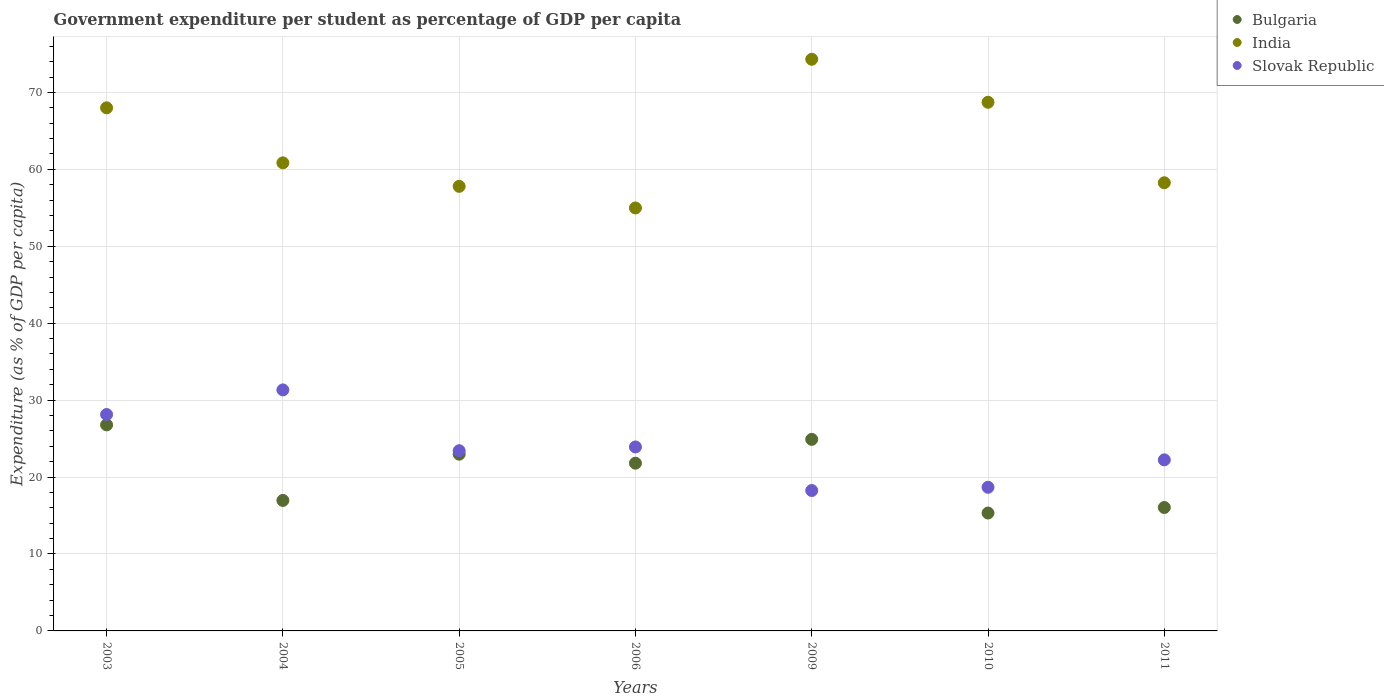What is the percentage of expenditure per student in Bulgaria in 2009?
Your answer should be compact. 24.9. Across all years, what is the maximum percentage of expenditure per student in Bulgaria?
Ensure brevity in your answer.  26.78. Across all years, what is the minimum percentage of expenditure per student in India?
Ensure brevity in your answer.  54.98. In which year was the percentage of expenditure per student in India maximum?
Provide a short and direct response. 2009. What is the total percentage of expenditure per student in India in the graph?
Your answer should be very brief. 442.9. What is the difference between the percentage of expenditure per student in India in 2003 and that in 2004?
Make the answer very short. 7.15. What is the difference between the percentage of expenditure per student in Slovak Republic in 2004 and the percentage of expenditure per student in India in 2009?
Your answer should be compact. -42.98. What is the average percentage of expenditure per student in Slovak Republic per year?
Give a very brief answer. 23.71. In the year 2005, what is the difference between the percentage of expenditure per student in Bulgaria and percentage of expenditure per student in India?
Offer a terse response. -34.82. What is the ratio of the percentage of expenditure per student in Slovak Republic in 2006 to that in 2011?
Offer a terse response. 1.08. Is the difference between the percentage of expenditure per student in Bulgaria in 2006 and 2010 greater than the difference between the percentage of expenditure per student in India in 2006 and 2010?
Ensure brevity in your answer.  Yes. What is the difference between the highest and the second highest percentage of expenditure per student in Slovak Republic?
Your answer should be very brief. 3.2. What is the difference between the highest and the lowest percentage of expenditure per student in Slovak Republic?
Your answer should be compact. 13.08. In how many years, is the percentage of expenditure per student in Slovak Republic greater than the average percentage of expenditure per student in Slovak Republic taken over all years?
Provide a short and direct response. 3. Does the percentage of expenditure per student in Slovak Republic monotonically increase over the years?
Make the answer very short. No. Is the percentage of expenditure per student in Slovak Republic strictly greater than the percentage of expenditure per student in Bulgaria over the years?
Provide a short and direct response. No. How many years are there in the graph?
Make the answer very short. 7. What is the difference between two consecutive major ticks on the Y-axis?
Offer a very short reply. 10. Where does the legend appear in the graph?
Make the answer very short. Top right. How many legend labels are there?
Your answer should be very brief. 3. How are the legend labels stacked?
Your answer should be compact. Vertical. What is the title of the graph?
Provide a short and direct response. Government expenditure per student as percentage of GDP per capita. What is the label or title of the X-axis?
Your answer should be very brief. Years. What is the label or title of the Y-axis?
Provide a succinct answer. Expenditure (as % of GDP per capita). What is the Expenditure (as % of GDP per capita) in Bulgaria in 2003?
Ensure brevity in your answer.  26.78. What is the Expenditure (as % of GDP per capita) of India in 2003?
Provide a short and direct response. 68. What is the Expenditure (as % of GDP per capita) in Slovak Republic in 2003?
Your answer should be very brief. 28.13. What is the Expenditure (as % of GDP per capita) of Bulgaria in 2004?
Provide a succinct answer. 16.96. What is the Expenditure (as % of GDP per capita) in India in 2004?
Your answer should be compact. 60.85. What is the Expenditure (as % of GDP per capita) in Slovak Republic in 2004?
Offer a terse response. 31.33. What is the Expenditure (as % of GDP per capita) in Bulgaria in 2005?
Your answer should be compact. 22.97. What is the Expenditure (as % of GDP per capita) in India in 2005?
Your response must be concise. 57.79. What is the Expenditure (as % of GDP per capita) of Slovak Republic in 2005?
Your answer should be very brief. 23.43. What is the Expenditure (as % of GDP per capita) of Bulgaria in 2006?
Provide a succinct answer. 21.8. What is the Expenditure (as % of GDP per capita) in India in 2006?
Offer a terse response. 54.98. What is the Expenditure (as % of GDP per capita) of Slovak Republic in 2006?
Provide a short and direct response. 23.92. What is the Expenditure (as % of GDP per capita) of Bulgaria in 2009?
Your response must be concise. 24.9. What is the Expenditure (as % of GDP per capita) in India in 2009?
Provide a short and direct response. 74.31. What is the Expenditure (as % of GDP per capita) of Slovak Republic in 2009?
Make the answer very short. 18.25. What is the Expenditure (as % of GDP per capita) in Bulgaria in 2010?
Your response must be concise. 15.33. What is the Expenditure (as % of GDP per capita) of India in 2010?
Offer a terse response. 68.72. What is the Expenditure (as % of GDP per capita) in Slovak Republic in 2010?
Offer a terse response. 18.67. What is the Expenditure (as % of GDP per capita) of Bulgaria in 2011?
Make the answer very short. 16.04. What is the Expenditure (as % of GDP per capita) of India in 2011?
Make the answer very short. 58.26. What is the Expenditure (as % of GDP per capita) of Slovak Republic in 2011?
Your answer should be compact. 22.24. Across all years, what is the maximum Expenditure (as % of GDP per capita) in Bulgaria?
Ensure brevity in your answer.  26.78. Across all years, what is the maximum Expenditure (as % of GDP per capita) of India?
Give a very brief answer. 74.31. Across all years, what is the maximum Expenditure (as % of GDP per capita) in Slovak Republic?
Provide a succinct answer. 31.33. Across all years, what is the minimum Expenditure (as % of GDP per capita) in Bulgaria?
Provide a succinct answer. 15.33. Across all years, what is the minimum Expenditure (as % of GDP per capita) of India?
Your answer should be compact. 54.98. Across all years, what is the minimum Expenditure (as % of GDP per capita) of Slovak Republic?
Provide a succinct answer. 18.25. What is the total Expenditure (as % of GDP per capita) in Bulgaria in the graph?
Make the answer very short. 144.8. What is the total Expenditure (as % of GDP per capita) of India in the graph?
Keep it short and to the point. 442.9. What is the total Expenditure (as % of GDP per capita) of Slovak Republic in the graph?
Make the answer very short. 165.96. What is the difference between the Expenditure (as % of GDP per capita) in Bulgaria in 2003 and that in 2004?
Ensure brevity in your answer.  9.82. What is the difference between the Expenditure (as % of GDP per capita) of India in 2003 and that in 2004?
Make the answer very short. 7.15. What is the difference between the Expenditure (as % of GDP per capita) in Slovak Republic in 2003 and that in 2004?
Offer a very short reply. -3.2. What is the difference between the Expenditure (as % of GDP per capita) in Bulgaria in 2003 and that in 2005?
Provide a short and direct response. 3.81. What is the difference between the Expenditure (as % of GDP per capita) in India in 2003 and that in 2005?
Make the answer very short. 10.21. What is the difference between the Expenditure (as % of GDP per capita) in Slovak Republic in 2003 and that in 2005?
Make the answer very short. 4.7. What is the difference between the Expenditure (as % of GDP per capita) of Bulgaria in 2003 and that in 2006?
Your response must be concise. 4.98. What is the difference between the Expenditure (as % of GDP per capita) of India in 2003 and that in 2006?
Your answer should be compact. 13.02. What is the difference between the Expenditure (as % of GDP per capita) of Slovak Republic in 2003 and that in 2006?
Your response must be concise. 4.21. What is the difference between the Expenditure (as % of GDP per capita) in Bulgaria in 2003 and that in 2009?
Keep it short and to the point. 1.88. What is the difference between the Expenditure (as % of GDP per capita) in India in 2003 and that in 2009?
Provide a short and direct response. -6.31. What is the difference between the Expenditure (as % of GDP per capita) of Slovak Republic in 2003 and that in 2009?
Your response must be concise. 9.88. What is the difference between the Expenditure (as % of GDP per capita) in Bulgaria in 2003 and that in 2010?
Provide a succinct answer. 11.46. What is the difference between the Expenditure (as % of GDP per capita) of India in 2003 and that in 2010?
Keep it short and to the point. -0.72. What is the difference between the Expenditure (as % of GDP per capita) in Slovak Republic in 2003 and that in 2010?
Your answer should be very brief. 9.46. What is the difference between the Expenditure (as % of GDP per capita) in Bulgaria in 2003 and that in 2011?
Offer a very short reply. 10.74. What is the difference between the Expenditure (as % of GDP per capita) of India in 2003 and that in 2011?
Provide a short and direct response. 9.74. What is the difference between the Expenditure (as % of GDP per capita) of Slovak Republic in 2003 and that in 2011?
Offer a terse response. 5.89. What is the difference between the Expenditure (as % of GDP per capita) in Bulgaria in 2004 and that in 2005?
Ensure brevity in your answer.  -6.01. What is the difference between the Expenditure (as % of GDP per capita) in India in 2004 and that in 2005?
Offer a terse response. 3.06. What is the difference between the Expenditure (as % of GDP per capita) of Slovak Republic in 2004 and that in 2005?
Ensure brevity in your answer.  7.9. What is the difference between the Expenditure (as % of GDP per capita) of Bulgaria in 2004 and that in 2006?
Your answer should be very brief. -4.84. What is the difference between the Expenditure (as % of GDP per capita) in India in 2004 and that in 2006?
Your response must be concise. 5.87. What is the difference between the Expenditure (as % of GDP per capita) in Slovak Republic in 2004 and that in 2006?
Make the answer very short. 7.42. What is the difference between the Expenditure (as % of GDP per capita) of Bulgaria in 2004 and that in 2009?
Offer a terse response. -7.94. What is the difference between the Expenditure (as % of GDP per capita) of India in 2004 and that in 2009?
Ensure brevity in your answer.  -13.47. What is the difference between the Expenditure (as % of GDP per capita) in Slovak Republic in 2004 and that in 2009?
Provide a short and direct response. 13.08. What is the difference between the Expenditure (as % of GDP per capita) in Bulgaria in 2004 and that in 2010?
Ensure brevity in your answer.  1.64. What is the difference between the Expenditure (as % of GDP per capita) of India in 2004 and that in 2010?
Your answer should be very brief. -7.87. What is the difference between the Expenditure (as % of GDP per capita) in Slovak Republic in 2004 and that in 2010?
Make the answer very short. 12.66. What is the difference between the Expenditure (as % of GDP per capita) of Bulgaria in 2004 and that in 2011?
Make the answer very short. 0.92. What is the difference between the Expenditure (as % of GDP per capita) in India in 2004 and that in 2011?
Keep it short and to the point. 2.59. What is the difference between the Expenditure (as % of GDP per capita) in Slovak Republic in 2004 and that in 2011?
Make the answer very short. 9.09. What is the difference between the Expenditure (as % of GDP per capita) of Bulgaria in 2005 and that in 2006?
Your answer should be compact. 1.17. What is the difference between the Expenditure (as % of GDP per capita) in India in 2005 and that in 2006?
Provide a short and direct response. 2.81. What is the difference between the Expenditure (as % of GDP per capita) in Slovak Republic in 2005 and that in 2006?
Provide a short and direct response. -0.49. What is the difference between the Expenditure (as % of GDP per capita) in Bulgaria in 2005 and that in 2009?
Provide a short and direct response. -1.93. What is the difference between the Expenditure (as % of GDP per capita) in India in 2005 and that in 2009?
Your answer should be compact. -16.52. What is the difference between the Expenditure (as % of GDP per capita) of Slovak Republic in 2005 and that in 2009?
Provide a short and direct response. 5.18. What is the difference between the Expenditure (as % of GDP per capita) of Bulgaria in 2005 and that in 2010?
Offer a terse response. 7.65. What is the difference between the Expenditure (as % of GDP per capita) of India in 2005 and that in 2010?
Provide a short and direct response. -10.93. What is the difference between the Expenditure (as % of GDP per capita) of Slovak Republic in 2005 and that in 2010?
Make the answer very short. 4.75. What is the difference between the Expenditure (as % of GDP per capita) of Bulgaria in 2005 and that in 2011?
Your answer should be compact. 6.93. What is the difference between the Expenditure (as % of GDP per capita) of India in 2005 and that in 2011?
Ensure brevity in your answer.  -0.47. What is the difference between the Expenditure (as % of GDP per capita) in Slovak Republic in 2005 and that in 2011?
Give a very brief answer. 1.19. What is the difference between the Expenditure (as % of GDP per capita) of Bulgaria in 2006 and that in 2009?
Offer a terse response. -3.1. What is the difference between the Expenditure (as % of GDP per capita) in India in 2006 and that in 2009?
Offer a terse response. -19.33. What is the difference between the Expenditure (as % of GDP per capita) in Slovak Republic in 2006 and that in 2009?
Give a very brief answer. 5.66. What is the difference between the Expenditure (as % of GDP per capita) in Bulgaria in 2006 and that in 2010?
Make the answer very short. 6.48. What is the difference between the Expenditure (as % of GDP per capita) in India in 2006 and that in 2010?
Ensure brevity in your answer.  -13.74. What is the difference between the Expenditure (as % of GDP per capita) of Slovak Republic in 2006 and that in 2010?
Your answer should be very brief. 5.24. What is the difference between the Expenditure (as % of GDP per capita) of Bulgaria in 2006 and that in 2011?
Make the answer very short. 5.76. What is the difference between the Expenditure (as % of GDP per capita) in India in 2006 and that in 2011?
Your answer should be very brief. -3.28. What is the difference between the Expenditure (as % of GDP per capita) in Slovak Republic in 2006 and that in 2011?
Offer a very short reply. 1.68. What is the difference between the Expenditure (as % of GDP per capita) in Bulgaria in 2009 and that in 2010?
Your response must be concise. 9.58. What is the difference between the Expenditure (as % of GDP per capita) of India in 2009 and that in 2010?
Keep it short and to the point. 5.59. What is the difference between the Expenditure (as % of GDP per capita) in Slovak Republic in 2009 and that in 2010?
Provide a short and direct response. -0.42. What is the difference between the Expenditure (as % of GDP per capita) of Bulgaria in 2009 and that in 2011?
Provide a succinct answer. 8.86. What is the difference between the Expenditure (as % of GDP per capita) in India in 2009 and that in 2011?
Your answer should be very brief. 16.05. What is the difference between the Expenditure (as % of GDP per capita) of Slovak Republic in 2009 and that in 2011?
Offer a terse response. -3.99. What is the difference between the Expenditure (as % of GDP per capita) of Bulgaria in 2010 and that in 2011?
Offer a very short reply. -0.72. What is the difference between the Expenditure (as % of GDP per capita) of India in 2010 and that in 2011?
Offer a very short reply. 10.46. What is the difference between the Expenditure (as % of GDP per capita) of Slovak Republic in 2010 and that in 2011?
Make the answer very short. -3.56. What is the difference between the Expenditure (as % of GDP per capita) of Bulgaria in 2003 and the Expenditure (as % of GDP per capita) of India in 2004?
Make the answer very short. -34.06. What is the difference between the Expenditure (as % of GDP per capita) of Bulgaria in 2003 and the Expenditure (as % of GDP per capita) of Slovak Republic in 2004?
Make the answer very short. -4.55. What is the difference between the Expenditure (as % of GDP per capita) in India in 2003 and the Expenditure (as % of GDP per capita) in Slovak Republic in 2004?
Provide a short and direct response. 36.67. What is the difference between the Expenditure (as % of GDP per capita) in Bulgaria in 2003 and the Expenditure (as % of GDP per capita) in India in 2005?
Your response must be concise. -31.01. What is the difference between the Expenditure (as % of GDP per capita) in Bulgaria in 2003 and the Expenditure (as % of GDP per capita) in Slovak Republic in 2005?
Your answer should be compact. 3.36. What is the difference between the Expenditure (as % of GDP per capita) in India in 2003 and the Expenditure (as % of GDP per capita) in Slovak Republic in 2005?
Ensure brevity in your answer.  44.57. What is the difference between the Expenditure (as % of GDP per capita) of Bulgaria in 2003 and the Expenditure (as % of GDP per capita) of India in 2006?
Your response must be concise. -28.2. What is the difference between the Expenditure (as % of GDP per capita) of Bulgaria in 2003 and the Expenditure (as % of GDP per capita) of Slovak Republic in 2006?
Provide a succinct answer. 2.87. What is the difference between the Expenditure (as % of GDP per capita) of India in 2003 and the Expenditure (as % of GDP per capita) of Slovak Republic in 2006?
Make the answer very short. 44.08. What is the difference between the Expenditure (as % of GDP per capita) of Bulgaria in 2003 and the Expenditure (as % of GDP per capita) of India in 2009?
Offer a terse response. -47.53. What is the difference between the Expenditure (as % of GDP per capita) of Bulgaria in 2003 and the Expenditure (as % of GDP per capita) of Slovak Republic in 2009?
Ensure brevity in your answer.  8.53. What is the difference between the Expenditure (as % of GDP per capita) of India in 2003 and the Expenditure (as % of GDP per capita) of Slovak Republic in 2009?
Offer a very short reply. 49.75. What is the difference between the Expenditure (as % of GDP per capita) in Bulgaria in 2003 and the Expenditure (as % of GDP per capita) in India in 2010?
Ensure brevity in your answer.  -41.94. What is the difference between the Expenditure (as % of GDP per capita) in Bulgaria in 2003 and the Expenditure (as % of GDP per capita) in Slovak Republic in 2010?
Provide a short and direct response. 8.11. What is the difference between the Expenditure (as % of GDP per capita) in India in 2003 and the Expenditure (as % of GDP per capita) in Slovak Republic in 2010?
Provide a short and direct response. 49.33. What is the difference between the Expenditure (as % of GDP per capita) in Bulgaria in 2003 and the Expenditure (as % of GDP per capita) in India in 2011?
Give a very brief answer. -31.47. What is the difference between the Expenditure (as % of GDP per capita) of Bulgaria in 2003 and the Expenditure (as % of GDP per capita) of Slovak Republic in 2011?
Provide a succinct answer. 4.55. What is the difference between the Expenditure (as % of GDP per capita) of India in 2003 and the Expenditure (as % of GDP per capita) of Slovak Republic in 2011?
Your answer should be compact. 45.76. What is the difference between the Expenditure (as % of GDP per capita) of Bulgaria in 2004 and the Expenditure (as % of GDP per capita) of India in 2005?
Your response must be concise. -40.83. What is the difference between the Expenditure (as % of GDP per capita) of Bulgaria in 2004 and the Expenditure (as % of GDP per capita) of Slovak Republic in 2005?
Offer a terse response. -6.46. What is the difference between the Expenditure (as % of GDP per capita) of India in 2004 and the Expenditure (as % of GDP per capita) of Slovak Republic in 2005?
Your answer should be very brief. 37.42. What is the difference between the Expenditure (as % of GDP per capita) of Bulgaria in 2004 and the Expenditure (as % of GDP per capita) of India in 2006?
Ensure brevity in your answer.  -38.02. What is the difference between the Expenditure (as % of GDP per capita) in Bulgaria in 2004 and the Expenditure (as % of GDP per capita) in Slovak Republic in 2006?
Provide a short and direct response. -6.95. What is the difference between the Expenditure (as % of GDP per capita) of India in 2004 and the Expenditure (as % of GDP per capita) of Slovak Republic in 2006?
Your response must be concise. 36.93. What is the difference between the Expenditure (as % of GDP per capita) of Bulgaria in 2004 and the Expenditure (as % of GDP per capita) of India in 2009?
Offer a very short reply. -57.35. What is the difference between the Expenditure (as % of GDP per capita) of Bulgaria in 2004 and the Expenditure (as % of GDP per capita) of Slovak Republic in 2009?
Your answer should be compact. -1.29. What is the difference between the Expenditure (as % of GDP per capita) in India in 2004 and the Expenditure (as % of GDP per capita) in Slovak Republic in 2009?
Ensure brevity in your answer.  42.59. What is the difference between the Expenditure (as % of GDP per capita) in Bulgaria in 2004 and the Expenditure (as % of GDP per capita) in India in 2010?
Provide a succinct answer. -51.76. What is the difference between the Expenditure (as % of GDP per capita) in Bulgaria in 2004 and the Expenditure (as % of GDP per capita) in Slovak Republic in 2010?
Keep it short and to the point. -1.71. What is the difference between the Expenditure (as % of GDP per capita) of India in 2004 and the Expenditure (as % of GDP per capita) of Slovak Republic in 2010?
Provide a succinct answer. 42.17. What is the difference between the Expenditure (as % of GDP per capita) in Bulgaria in 2004 and the Expenditure (as % of GDP per capita) in India in 2011?
Offer a very short reply. -41.29. What is the difference between the Expenditure (as % of GDP per capita) in Bulgaria in 2004 and the Expenditure (as % of GDP per capita) in Slovak Republic in 2011?
Your answer should be compact. -5.27. What is the difference between the Expenditure (as % of GDP per capita) in India in 2004 and the Expenditure (as % of GDP per capita) in Slovak Republic in 2011?
Provide a succinct answer. 38.61. What is the difference between the Expenditure (as % of GDP per capita) in Bulgaria in 2005 and the Expenditure (as % of GDP per capita) in India in 2006?
Provide a short and direct response. -32.01. What is the difference between the Expenditure (as % of GDP per capita) in Bulgaria in 2005 and the Expenditure (as % of GDP per capita) in Slovak Republic in 2006?
Your answer should be very brief. -0.94. What is the difference between the Expenditure (as % of GDP per capita) of India in 2005 and the Expenditure (as % of GDP per capita) of Slovak Republic in 2006?
Offer a terse response. 33.87. What is the difference between the Expenditure (as % of GDP per capita) of Bulgaria in 2005 and the Expenditure (as % of GDP per capita) of India in 2009?
Provide a succinct answer. -51.34. What is the difference between the Expenditure (as % of GDP per capita) of Bulgaria in 2005 and the Expenditure (as % of GDP per capita) of Slovak Republic in 2009?
Ensure brevity in your answer.  4.72. What is the difference between the Expenditure (as % of GDP per capita) in India in 2005 and the Expenditure (as % of GDP per capita) in Slovak Republic in 2009?
Offer a very short reply. 39.54. What is the difference between the Expenditure (as % of GDP per capita) of Bulgaria in 2005 and the Expenditure (as % of GDP per capita) of India in 2010?
Provide a succinct answer. -45.75. What is the difference between the Expenditure (as % of GDP per capita) of Bulgaria in 2005 and the Expenditure (as % of GDP per capita) of Slovak Republic in 2010?
Offer a terse response. 4.3. What is the difference between the Expenditure (as % of GDP per capita) in India in 2005 and the Expenditure (as % of GDP per capita) in Slovak Republic in 2010?
Your response must be concise. 39.12. What is the difference between the Expenditure (as % of GDP per capita) of Bulgaria in 2005 and the Expenditure (as % of GDP per capita) of India in 2011?
Give a very brief answer. -35.28. What is the difference between the Expenditure (as % of GDP per capita) of Bulgaria in 2005 and the Expenditure (as % of GDP per capita) of Slovak Republic in 2011?
Your answer should be very brief. 0.74. What is the difference between the Expenditure (as % of GDP per capita) in India in 2005 and the Expenditure (as % of GDP per capita) in Slovak Republic in 2011?
Offer a very short reply. 35.55. What is the difference between the Expenditure (as % of GDP per capita) in Bulgaria in 2006 and the Expenditure (as % of GDP per capita) in India in 2009?
Keep it short and to the point. -52.51. What is the difference between the Expenditure (as % of GDP per capita) of Bulgaria in 2006 and the Expenditure (as % of GDP per capita) of Slovak Republic in 2009?
Offer a very short reply. 3.55. What is the difference between the Expenditure (as % of GDP per capita) in India in 2006 and the Expenditure (as % of GDP per capita) in Slovak Republic in 2009?
Offer a very short reply. 36.73. What is the difference between the Expenditure (as % of GDP per capita) of Bulgaria in 2006 and the Expenditure (as % of GDP per capita) of India in 2010?
Make the answer very short. -46.92. What is the difference between the Expenditure (as % of GDP per capita) in Bulgaria in 2006 and the Expenditure (as % of GDP per capita) in Slovak Republic in 2010?
Offer a very short reply. 3.13. What is the difference between the Expenditure (as % of GDP per capita) of India in 2006 and the Expenditure (as % of GDP per capita) of Slovak Republic in 2010?
Provide a short and direct response. 36.31. What is the difference between the Expenditure (as % of GDP per capita) in Bulgaria in 2006 and the Expenditure (as % of GDP per capita) in India in 2011?
Give a very brief answer. -36.45. What is the difference between the Expenditure (as % of GDP per capita) in Bulgaria in 2006 and the Expenditure (as % of GDP per capita) in Slovak Republic in 2011?
Give a very brief answer. -0.43. What is the difference between the Expenditure (as % of GDP per capita) in India in 2006 and the Expenditure (as % of GDP per capita) in Slovak Republic in 2011?
Offer a very short reply. 32.74. What is the difference between the Expenditure (as % of GDP per capita) of Bulgaria in 2009 and the Expenditure (as % of GDP per capita) of India in 2010?
Ensure brevity in your answer.  -43.82. What is the difference between the Expenditure (as % of GDP per capita) in Bulgaria in 2009 and the Expenditure (as % of GDP per capita) in Slovak Republic in 2010?
Provide a short and direct response. 6.23. What is the difference between the Expenditure (as % of GDP per capita) in India in 2009 and the Expenditure (as % of GDP per capita) in Slovak Republic in 2010?
Give a very brief answer. 55.64. What is the difference between the Expenditure (as % of GDP per capita) of Bulgaria in 2009 and the Expenditure (as % of GDP per capita) of India in 2011?
Provide a succinct answer. -33.35. What is the difference between the Expenditure (as % of GDP per capita) in Bulgaria in 2009 and the Expenditure (as % of GDP per capita) in Slovak Republic in 2011?
Provide a short and direct response. 2.66. What is the difference between the Expenditure (as % of GDP per capita) in India in 2009 and the Expenditure (as % of GDP per capita) in Slovak Republic in 2011?
Make the answer very short. 52.07. What is the difference between the Expenditure (as % of GDP per capita) of Bulgaria in 2010 and the Expenditure (as % of GDP per capita) of India in 2011?
Offer a terse response. -42.93. What is the difference between the Expenditure (as % of GDP per capita) in Bulgaria in 2010 and the Expenditure (as % of GDP per capita) in Slovak Republic in 2011?
Ensure brevity in your answer.  -6.91. What is the difference between the Expenditure (as % of GDP per capita) of India in 2010 and the Expenditure (as % of GDP per capita) of Slovak Republic in 2011?
Your answer should be compact. 46.48. What is the average Expenditure (as % of GDP per capita) of Bulgaria per year?
Offer a terse response. 20.68. What is the average Expenditure (as % of GDP per capita) of India per year?
Ensure brevity in your answer.  63.27. What is the average Expenditure (as % of GDP per capita) of Slovak Republic per year?
Provide a succinct answer. 23.71. In the year 2003, what is the difference between the Expenditure (as % of GDP per capita) in Bulgaria and Expenditure (as % of GDP per capita) in India?
Give a very brief answer. -41.21. In the year 2003, what is the difference between the Expenditure (as % of GDP per capita) of Bulgaria and Expenditure (as % of GDP per capita) of Slovak Republic?
Your answer should be very brief. -1.34. In the year 2003, what is the difference between the Expenditure (as % of GDP per capita) in India and Expenditure (as % of GDP per capita) in Slovak Republic?
Provide a short and direct response. 39.87. In the year 2004, what is the difference between the Expenditure (as % of GDP per capita) in Bulgaria and Expenditure (as % of GDP per capita) in India?
Ensure brevity in your answer.  -43.88. In the year 2004, what is the difference between the Expenditure (as % of GDP per capita) in Bulgaria and Expenditure (as % of GDP per capita) in Slovak Republic?
Keep it short and to the point. -14.37. In the year 2004, what is the difference between the Expenditure (as % of GDP per capita) in India and Expenditure (as % of GDP per capita) in Slovak Republic?
Offer a very short reply. 29.52. In the year 2005, what is the difference between the Expenditure (as % of GDP per capita) of Bulgaria and Expenditure (as % of GDP per capita) of India?
Your answer should be very brief. -34.82. In the year 2005, what is the difference between the Expenditure (as % of GDP per capita) in Bulgaria and Expenditure (as % of GDP per capita) in Slovak Republic?
Provide a succinct answer. -0.45. In the year 2005, what is the difference between the Expenditure (as % of GDP per capita) in India and Expenditure (as % of GDP per capita) in Slovak Republic?
Keep it short and to the point. 34.36. In the year 2006, what is the difference between the Expenditure (as % of GDP per capita) of Bulgaria and Expenditure (as % of GDP per capita) of India?
Make the answer very short. -33.18. In the year 2006, what is the difference between the Expenditure (as % of GDP per capita) in Bulgaria and Expenditure (as % of GDP per capita) in Slovak Republic?
Your response must be concise. -2.11. In the year 2006, what is the difference between the Expenditure (as % of GDP per capita) of India and Expenditure (as % of GDP per capita) of Slovak Republic?
Your response must be concise. 31.06. In the year 2009, what is the difference between the Expenditure (as % of GDP per capita) of Bulgaria and Expenditure (as % of GDP per capita) of India?
Your answer should be very brief. -49.41. In the year 2009, what is the difference between the Expenditure (as % of GDP per capita) in Bulgaria and Expenditure (as % of GDP per capita) in Slovak Republic?
Your answer should be compact. 6.65. In the year 2009, what is the difference between the Expenditure (as % of GDP per capita) of India and Expenditure (as % of GDP per capita) of Slovak Republic?
Offer a terse response. 56.06. In the year 2010, what is the difference between the Expenditure (as % of GDP per capita) of Bulgaria and Expenditure (as % of GDP per capita) of India?
Provide a succinct answer. -53.39. In the year 2010, what is the difference between the Expenditure (as % of GDP per capita) of Bulgaria and Expenditure (as % of GDP per capita) of Slovak Republic?
Provide a short and direct response. -3.35. In the year 2010, what is the difference between the Expenditure (as % of GDP per capita) of India and Expenditure (as % of GDP per capita) of Slovak Republic?
Your answer should be compact. 50.05. In the year 2011, what is the difference between the Expenditure (as % of GDP per capita) in Bulgaria and Expenditure (as % of GDP per capita) in India?
Your answer should be compact. -42.21. In the year 2011, what is the difference between the Expenditure (as % of GDP per capita) of Bulgaria and Expenditure (as % of GDP per capita) of Slovak Republic?
Provide a succinct answer. -6.19. In the year 2011, what is the difference between the Expenditure (as % of GDP per capita) of India and Expenditure (as % of GDP per capita) of Slovak Republic?
Your answer should be very brief. 36.02. What is the ratio of the Expenditure (as % of GDP per capita) in Bulgaria in 2003 to that in 2004?
Make the answer very short. 1.58. What is the ratio of the Expenditure (as % of GDP per capita) of India in 2003 to that in 2004?
Provide a short and direct response. 1.12. What is the ratio of the Expenditure (as % of GDP per capita) in Slovak Republic in 2003 to that in 2004?
Keep it short and to the point. 0.9. What is the ratio of the Expenditure (as % of GDP per capita) of Bulgaria in 2003 to that in 2005?
Your answer should be compact. 1.17. What is the ratio of the Expenditure (as % of GDP per capita) in India in 2003 to that in 2005?
Keep it short and to the point. 1.18. What is the ratio of the Expenditure (as % of GDP per capita) in Slovak Republic in 2003 to that in 2005?
Give a very brief answer. 1.2. What is the ratio of the Expenditure (as % of GDP per capita) of Bulgaria in 2003 to that in 2006?
Ensure brevity in your answer.  1.23. What is the ratio of the Expenditure (as % of GDP per capita) of India in 2003 to that in 2006?
Give a very brief answer. 1.24. What is the ratio of the Expenditure (as % of GDP per capita) of Slovak Republic in 2003 to that in 2006?
Offer a very short reply. 1.18. What is the ratio of the Expenditure (as % of GDP per capita) of Bulgaria in 2003 to that in 2009?
Offer a terse response. 1.08. What is the ratio of the Expenditure (as % of GDP per capita) in India in 2003 to that in 2009?
Make the answer very short. 0.92. What is the ratio of the Expenditure (as % of GDP per capita) of Slovak Republic in 2003 to that in 2009?
Offer a terse response. 1.54. What is the ratio of the Expenditure (as % of GDP per capita) of Bulgaria in 2003 to that in 2010?
Make the answer very short. 1.75. What is the ratio of the Expenditure (as % of GDP per capita) in Slovak Republic in 2003 to that in 2010?
Keep it short and to the point. 1.51. What is the ratio of the Expenditure (as % of GDP per capita) of Bulgaria in 2003 to that in 2011?
Keep it short and to the point. 1.67. What is the ratio of the Expenditure (as % of GDP per capita) of India in 2003 to that in 2011?
Your response must be concise. 1.17. What is the ratio of the Expenditure (as % of GDP per capita) in Slovak Republic in 2003 to that in 2011?
Offer a terse response. 1.26. What is the ratio of the Expenditure (as % of GDP per capita) in Bulgaria in 2004 to that in 2005?
Ensure brevity in your answer.  0.74. What is the ratio of the Expenditure (as % of GDP per capita) of India in 2004 to that in 2005?
Make the answer very short. 1.05. What is the ratio of the Expenditure (as % of GDP per capita) in Slovak Republic in 2004 to that in 2005?
Your answer should be compact. 1.34. What is the ratio of the Expenditure (as % of GDP per capita) in Bulgaria in 2004 to that in 2006?
Offer a terse response. 0.78. What is the ratio of the Expenditure (as % of GDP per capita) in India in 2004 to that in 2006?
Offer a terse response. 1.11. What is the ratio of the Expenditure (as % of GDP per capita) of Slovak Republic in 2004 to that in 2006?
Your answer should be very brief. 1.31. What is the ratio of the Expenditure (as % of GDP per capita) in Bulgaria in 2004 to that in 2009?
Offer a very short reply. 0.68. What is the ratio of the Expenditure (as % of GDP per capita) in India in 2004 to that in 2009?
Your answer should be very brief. 0.82. What is the ratio of the Expenditure (as % of GDP per capita) in Slovak Republic in 2004 to that in 2009?
Provide a short and direct response. 1.72. What is the ratio of the Expenditure (as % of GDP per capita) in Bulgaria in 2004 to that in 2010?
Provide a succinct answer. 1.11. What is the ratio of the Expenditure (as % of GDP per capita) of India in 2004 to that in 2010?
Provide a succinct answer. 0.89. What is the ratio of the Expenditure (as % of GDP per capita) in Slovak Republic in 2004 to that in 2010?
Your answer should be very brief. 1.68. What is the ratio of the Expenditure (as % of GDP per capita) in Bulgaria in 2004 to that in 2011?
Provide a succinct answer. 1.06. What is the ratio of the Expenditure (as % of GDP per capita) in India in 2004 to that in 2011?
Your response must be concise. 1.04. What is the ratio of the Expenditure (as % of GDP per capita) in Slovak Republic in 2004 to that in 2011?
Offer a terse response. 1.41. What is the ratio of the Expenditure (as % of GDP per capita) of Bulgaria in 2005 to that in 2006?
Give a very brief answer. 1.05. What is the ratio of the Expenditure (as % of GDP per capita) of India in 2005 to that in 2006?
Your answer should be very brief. 1.05. What is the ratio of the Expenditure (as % of GDP per capita) in Slovak Republic in 2005 to that in 2006?
Your response must be concise. 0.98. What is the ratio of the Expenditure (as % of GDP per capita) in Bulgaria in 2005 to that in 2009?
Offer a terse response. 0.92. What is the ratio of the Expenditure (as % of GDP per capita) in India in 2005 to that in 2009?
Make the answer very short. 0.78. What is the ratio of the Expenditure (as % of GDP per capita) in Slovak Republic in 2005 to that in 2009?
Offer a terse response. 1.28. What is the ratio of the Expenditure (as % of GDP per capita) of Bulgaria in 2005 to that in 2010?
Your answer should be compact. 1.5. What is the ratio of the Expenditure (as % of GDP per capita) of India in 2005 to that in 2010?
Your answer should be very brief. 0.84. What is the ratio of the Expenditure (as % of GDP per capita) of Slovak Republic in 2005 to that in 2010?
Your response must be concise. 1.25. What is the ratio of the Expenditure (as % of GDP per capita) of Bulgaria in 2005 to that in 2011?
Your answer should be very brief. 1.43. What is the ratio of the Expenditure (as % of GDP per capita) in Slovak Republic in 2005 to that in 2011?
Provide a short and direct response. 1.05. What is the ratio of the Expenditure (as % of GDP per capita) in Bulgaria in 2006 to that in 2009?
Keep it short and to the point. 0.88. What is the ratio of the Expenditure (as % of GDP per capita) in India in 2006 to that in 2009?
Offer a terse response. 0.74. What is the ratio of the Expenditure (as % of GDP per capita) of Slovak Republic in 2006 to that in 2009?
Offer a terse response. 1.31. What is the ratio of the Expenditure (as % of GDP per capita) of Bulgaria in 2006 to that in 2010?
Provide a succinct answer. 1.42. What is the ratio of the Expenditure (as % of GDP per capita) of India in 2006 to that in 2010?
Make the answer very short. 0.8. What is the ratio of the Expenditure (as % of GDP per capita) in Slovak Republic in 2006 to that in 2010?
Provide a short and direct response. 1.28. What is the ratio of the Expenditure (as % of GDP per capita) in Bulgaria in 2006 to that in 2011?
Provide a short and direct response. 1.36. What is the ratio of the Expenditure (as % of GDP per capita) in India in 2006 to that in 2011?
Provide a short and direct response. 0.94. What is the ratio of the Expenditure (as % of GDP per capita) of Slovak Republic in 2006 to that in 2011?
Your response must be concise. 1.08. What is the ratio of the Expenditure (as % of GDP per capita) in Bulgaria in 2009 to that in 2010?
Offer a very short reply. 1.62. What is the ratio of the Expenditure (as % of GDP per capita) in India in 2009 to that in 2010?
Provide a short and direct response. 1.08. What is the ratio of the Expenditure (as % of GDP per capita) in Slovak Republic in 2009 to that in 2010?
Your response must be concise. 0.98. What is the ratio of the Expenditure (as % of GDP per capita) in Bulgaria in 2009 to that in 2011?
Provide a succinct answer. 1.55. What is the ratio of the Expenditure (as % of GDP per capita) of India in 2009 to that in 2011?
Provide a succinct answer. 1.28. What is the ratio of the Expenditure (as % of GDP per capita) in Slovak Republic in 2009 to that in 2011?
Offer a very short reply. 0.82. What is the ratio of the Expenditure (as % of GDP per capita) in Bulgaria in 2010 to that in 2011?
Ensure brevity in your answer.  0.96. What is the ratio of the Expenditure (as % of GDP per capita) of India in 2010 to that in 2011?
Keep it short and to the point. 1.18. What is the ratio of the Expenditure (as % of GDP per capita) in Slovak Republic in 2010 to that in 2011?
Offer a very short reply. 0.84. What is the difference between the highest and the second highest Expenditure (as % of GDP per capita) in Bulgaria?
Ensure brevity in your answer.  1.88. What is the difference between the highest and the second highest Expenditure (as % of GDP per capita) in India?
Provide a succinct answer. 5.59. What is the difference between the highest and the second highest Expenditure (as % of GDP per capita) of Slovak Republic?
Ensure brevity in your answer.  3.2. What is the difference between the highest and the lowest Expenditure (as % of GDP per capita) in Bulgaria?
Provide a succinct answer. 11.46. What is the difference between the highest and the lowest Expenditure (as % of GDP per capita) of India?
Keep it short and to the point. 19.33. What is the difference between the highest and the lowest Expenditure (as % of GDP per capita) of Slovak Republic?
Offer a very short reply. 13.08. 